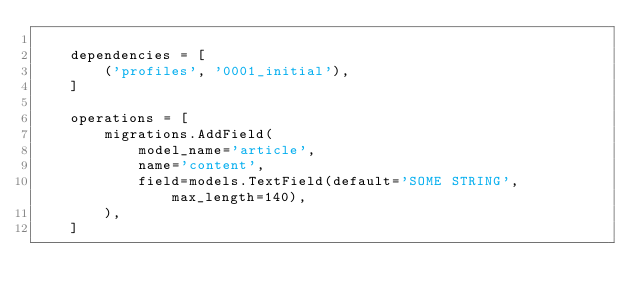Convert code to text. <code><loc_0><loc_0><loc_500><loc_500><_Python_>
    dependencies = [
        ('profiles', '0001_initial'),
    ]

    operations = [
        migrations.AddField(
            model_name='article',
            name='content',
            field=models.TextField(default='SOME STRING', max_length=140),
        ),
    ]
</code> 